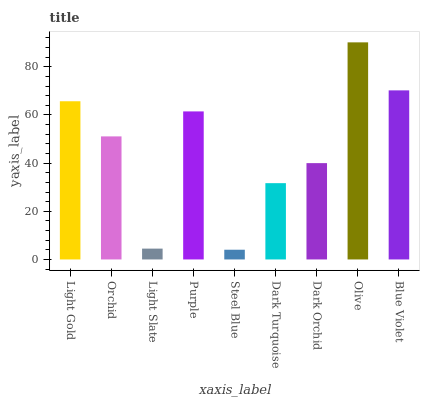Is Steel Blue the minimum?
Answer yes or no. Yes. Is Olive the maximum?
Answer yes or no. Yes. Is Orchid the minimum?
Answer yes or no. No. Is Orchid the maximum?
Answer yes or no. No. Is Light Gold greater than Orchid?
Answer yes or no. Yes. Is Orchid less than Light Gold?
Answer yes or no. Yes. Is Orchid greater than Light Gold?
Answer yes or no. No. Is Light Gold less than Orchid?
Answer yes or no. No. Is Orchid the high median?
Answer yes or no. Yes. Is Orchid the low median?
Answer yes or no. Yes. Is Steel Blue the high median?
Answer yes or no. No. Is Light Slate the low median?
Answer yes or no. No. 